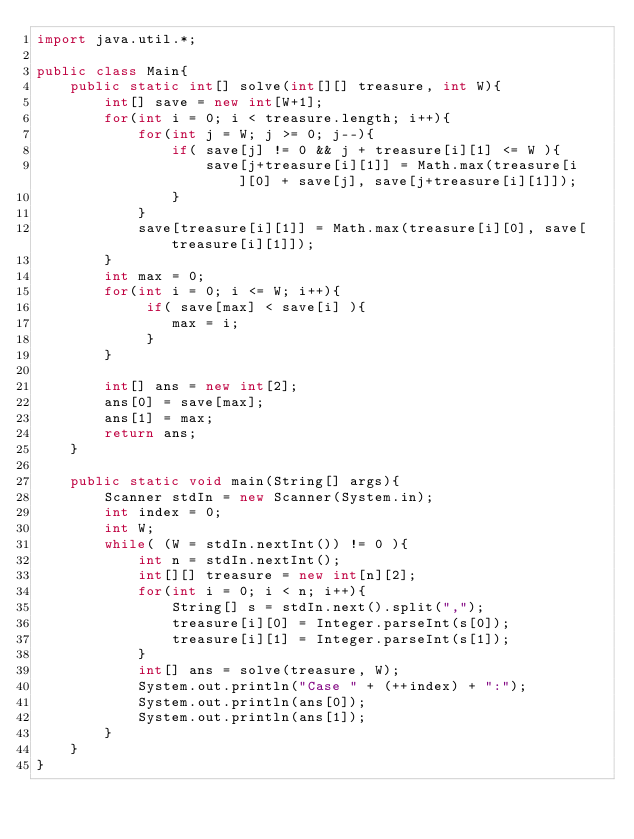<code> <loc_0><loc_0><loc_500><loc_500><_Java_>import java.util.*;
 
public class Main{
    public static int[] solve(int[][] treasure, int W){
        int[] save = new int[W+1];
        for(int i = 0; i < treasure.length; i++){
            for(int j = W; j >= 0; j--){
                if( save[j] != 0 && j + treasure[i][1] <= W ){
                    save[j+treasure[i][1]] = Math.max(treasure[i][0] + save[j], save[j+treasure[i][1]]);
                }
            }
            save[treasure[i][1]] = Math.max(treasure[i][0], save[treasure[i][1]]);
        }
        int max = 0;
        for(int i = 0; i <= W; i++){
             if( save[max] < save[i] ){
                max = i;
             }
        }
     
        int[] ans = new int[2];
        ans[0] = save[max];
        ans[1] = max;
        return ans;
    }
         
    public static void main(String[] args){
        Scanner stdIn = new Scanner(System.in);
        int index = 0;
        int W;
        while( (W = stdIn.nextInt()) != 0 ){
            int n = stdIn.nextInt();
            int[][] treasure = new int[n][2];
            for(int i = 0; i < n; i++){
                String[] s = stdIn.next().split(",");
                treasure[i][0] = Integer.parseInt(s[0]);
                treasure[i][1] = Integer.parseInt(s[1]);
            }
            int[] ans = solve(treasure, W);
            System.out.println("Case " + (++index) + ":");
            System.out.println(ans[0]);
            System.out.println(ans[1]);
        }
    }
}</code> 